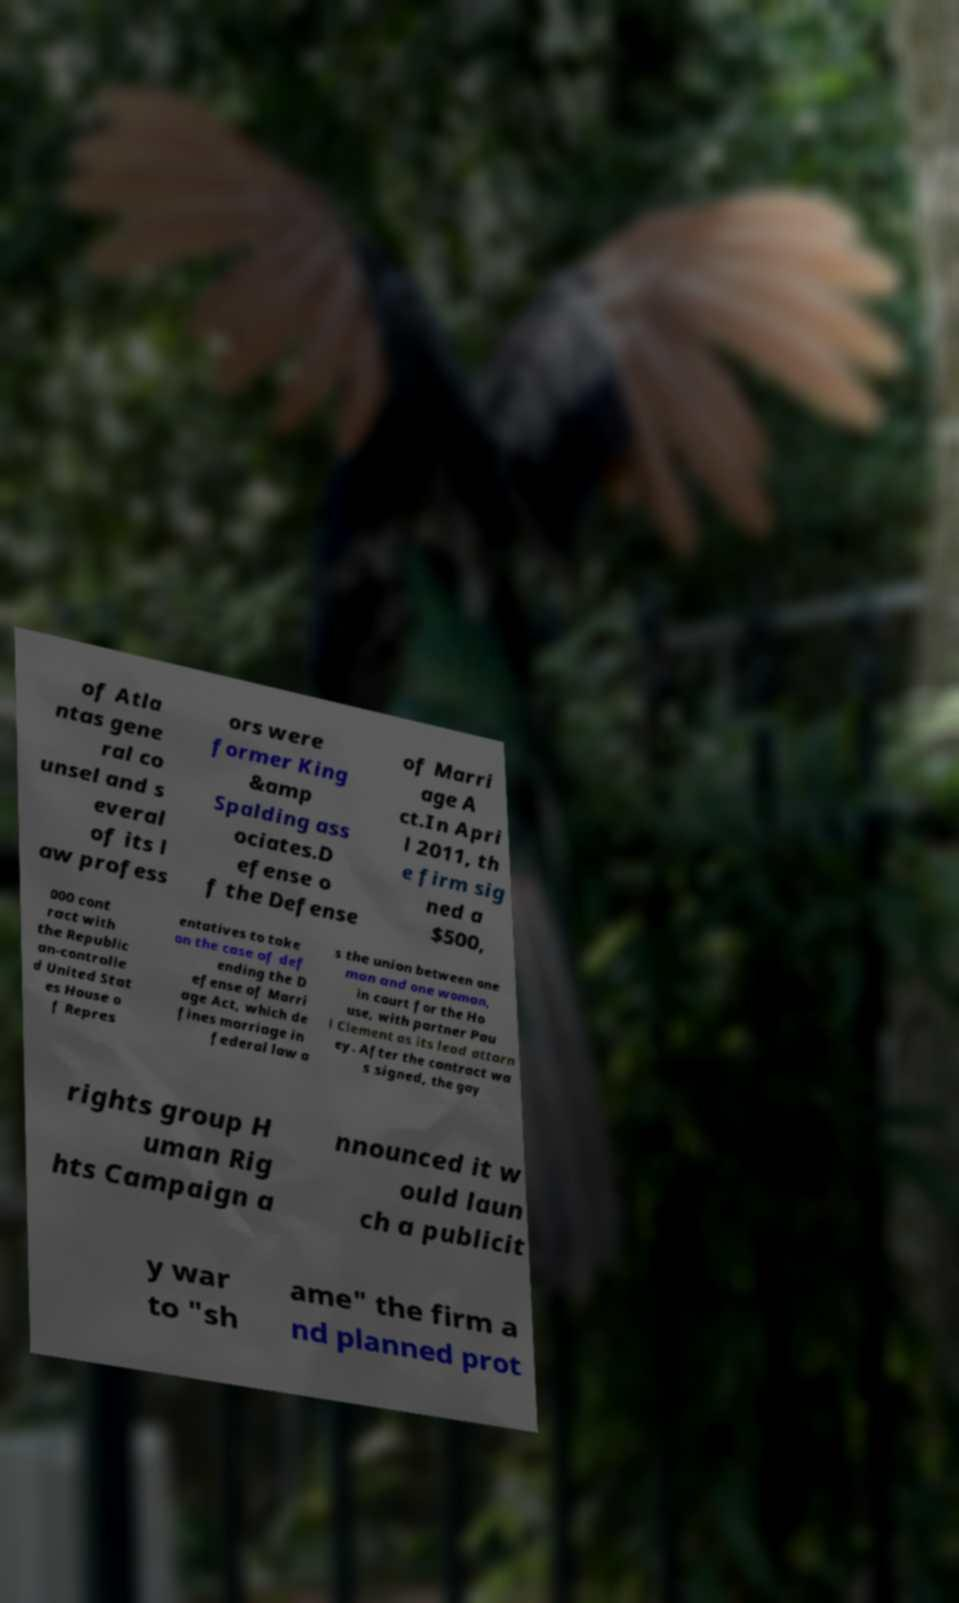Can you read and provide the text displayed in the image?This photo seems to have some interesting text. Can you extract and type it out for me? of Atla ntas gene ral co unsel and s everal of its l aw profess ors were former King &amp Spalding ass ociates.D efense o f the Defense of Marri age A ct.In Apri l 2011, th e firm sig ned a $500, 000 cont ract with the Republic an-controlle d United Stat es House o f Repres entatives to take on the case of def ending the D efense of Marri age Act, which de fines marriage in federal law a s the union between one man and one woman, in court for the Ho use, with partner Pau l Clement as its lead attorn ey. After the contract wa s signed, the gay rights group H uman Rig hts Campaign a nnounced it w ould laun ch a publicit y war to "sh ame" the firm a nd planned prot 